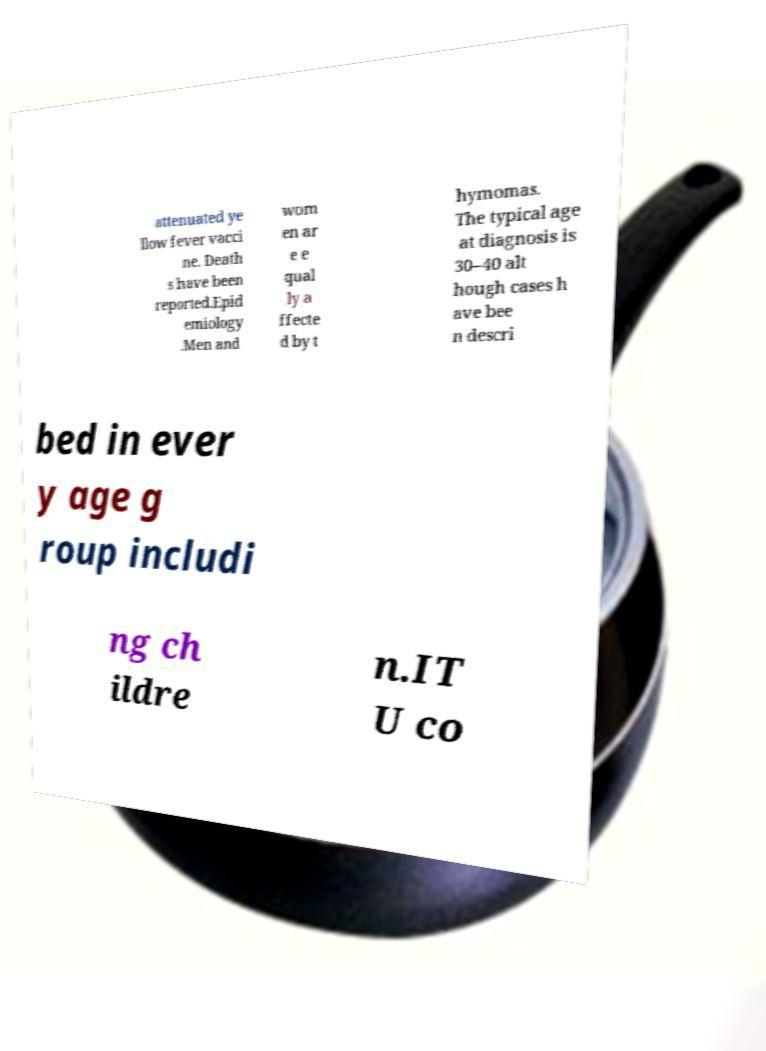Could you extract and type out the text from this image? attenuated ye llow fever vacci ne. Death s have been reported.Epid emiology .Men and wom en ar e e qual ly a ffecte d by t hymomas. The typical age at diagnosis is 30–40 alt hough cases h ave bee n descri bed in ever y age g roup includi ng ch ildre n.IT U co 